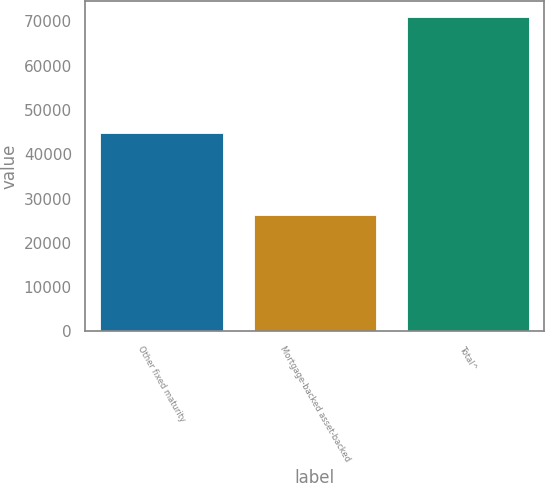<chart> <loc_0><loc_0><loc_500><loc_500><bar_chart><fcel>Other fixed maturity<fcel>Mortgage-backed asset-backed<fcel>Total^<nl><fcel>44758<fcel>26312<fcel>71070<nl></chart> 